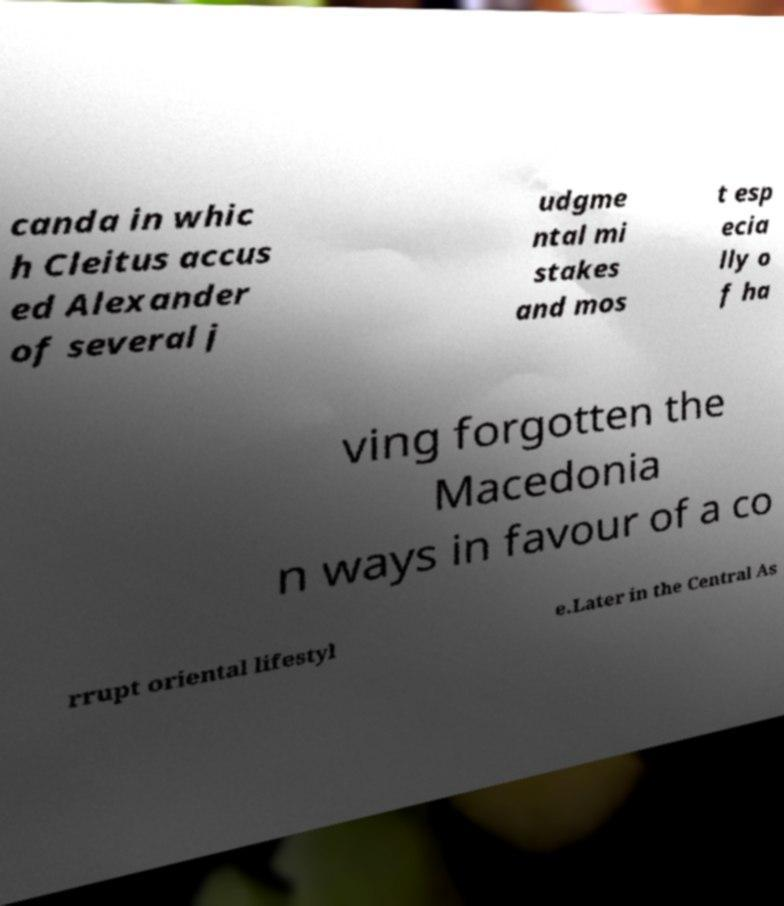What messages or text are displayed in this image? I need them in a readable, typed format. canda in whic h Cleitus accus ed Alexander of several j udgme ntal mi stakes and mos t esp ecia lly o f ha ving forgotten the Macedonia n ways in favour of a co rrupt oriental lifestyl e.Later in the Central As 